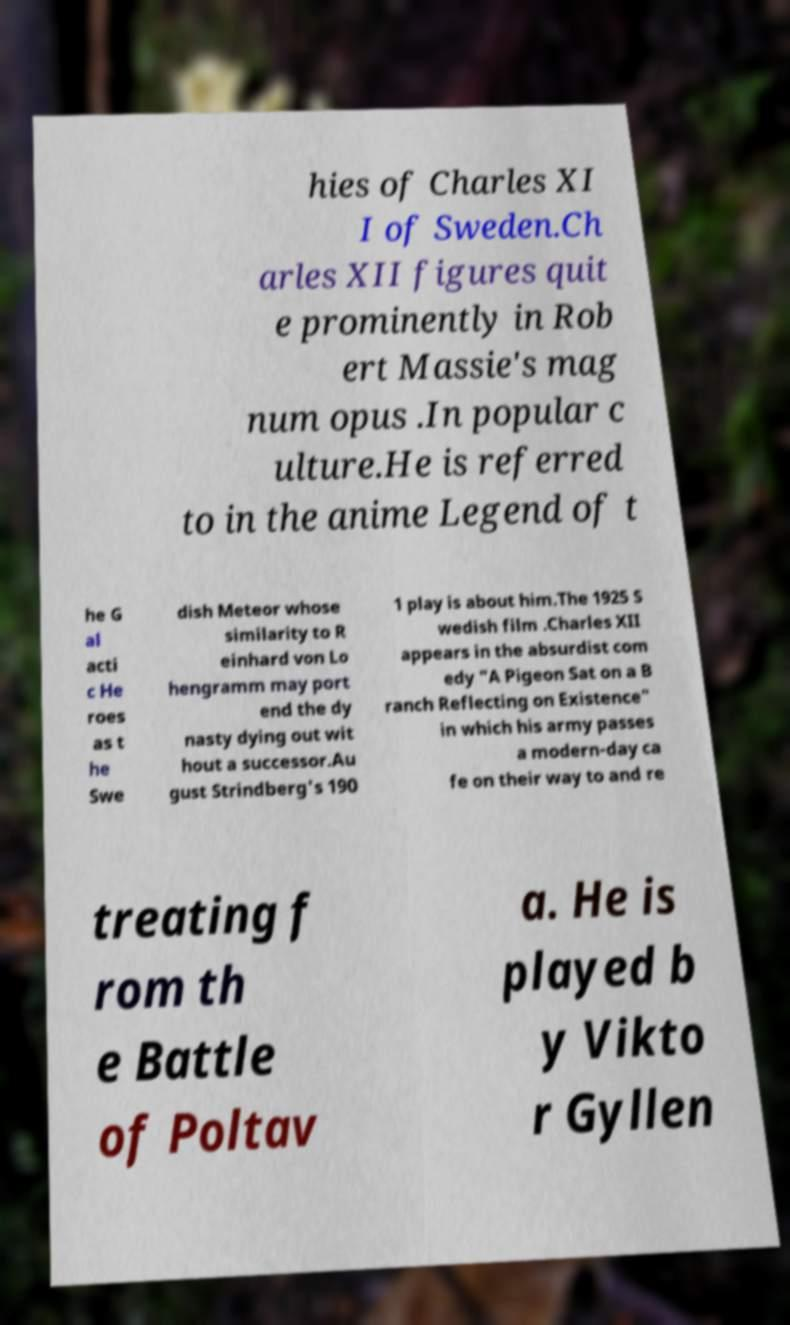Could you extract and type out the text from this image? hies of Charles XI I of Sweden.Ch arles XII figures quit e prominently in Rob ert Massie's mag num opus .In popular c ulture.He is referred to in the anime Legend of t he G al acti c He roes as t he Swe dish Meteor whose similarity to R einhard von Lo hengramm may port end the dy nasty dying out wit hout a successor.Au gust Strindberg's 190 1 play is about him.The 1925 S wedish film .Charles XII appears in the absurdist com edy "A Pigeon Sat on a B ranch Reflecting on Existence" in which his army passes a modern-day ca fe on their way to and re treating f rom th e Battle of Poltav a. He is played b y Vikto r Gyllen 